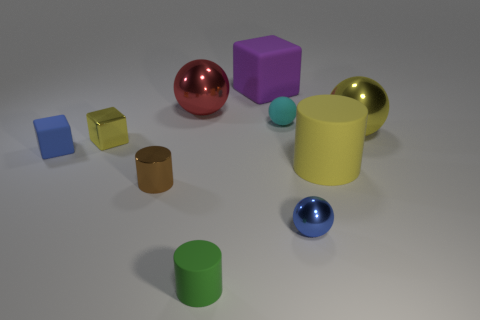Which object in the image stands out the most to you? The red sphere stands out due to its vibrant color and reflective surface which contrasts with the more subdued hues and textures of the surrounding objects. Is there a reason why it might stand out? From a visual perspective, the red sphere contrasts in color with its environment, drawing attention. Red is also a color that naturally draws the eye, and the sphere's position in the middle of the composition further adds to its visual prominence. 